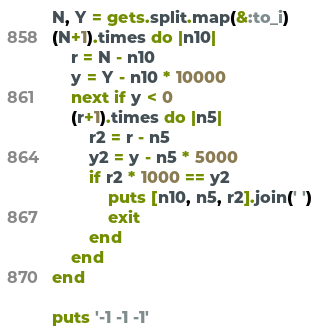Convert code to text. <code><loc_0><loc_0><loc_500><loc_500><_Ruby_>N, Y = gets.split.map(&:to_i)
(N+1).times do |n10|
    r = N - n10
    y = Y - n10 * 10000
    next if y < 0
    (r+1).times do |n5|
        r2 = r - n5
        y2 = y - n5 * 5000
        if r2 * 1000 == y2
            puts [n10, n5, r2].join(' ')
            exit
        end
    end
end

puts '-1 -1 -1'</code> 